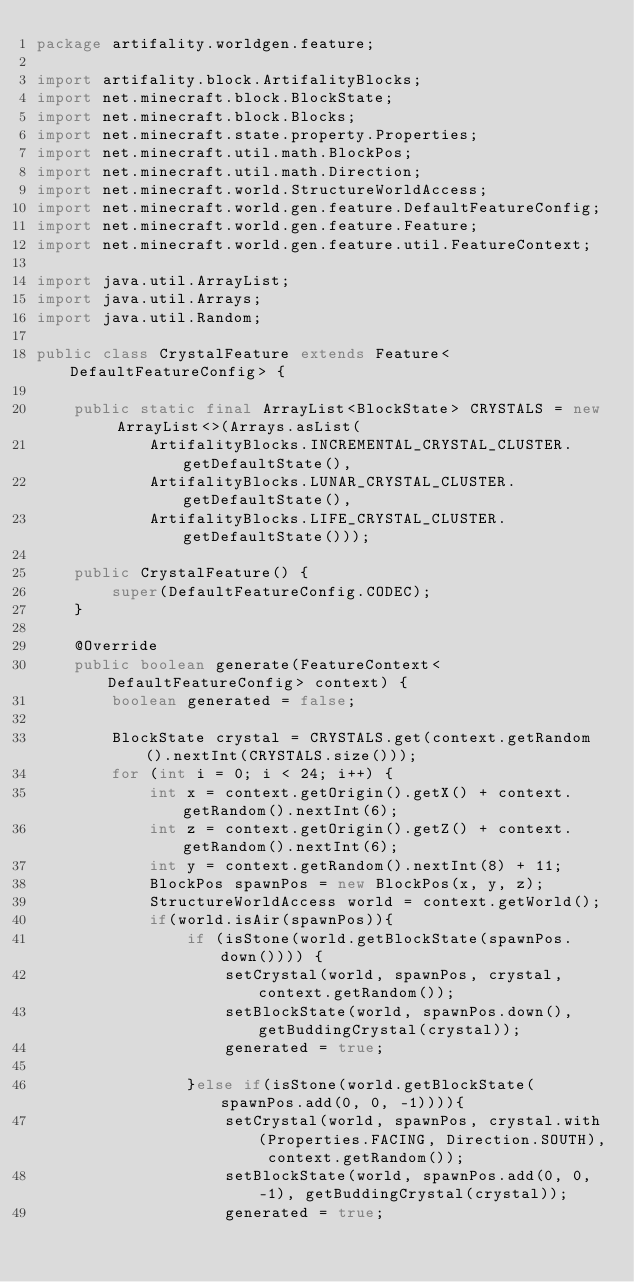Convert code to text. <code><loc_0><loc_0><loc_500><loc_500><_Java_>package artifality.worldgen.feature;

import artifality.block.ArtifalityBlocks;
import net.minecraft.block.BlockState;
import net.minecraft.block.Blocks;
import net.minecraft.state.property.Properties;
import net.minecraft.util.math.BlockPos;
import net.minecraft.util.math.Direction;
import net.minecraft.world.StructureWorldAccess;
import net.minecraft.world.gen.feature.DefaultFeatureConfig;
import net.minecraft.world.gen.feature.Feature;
import net.minecraft.world.gen.feature.util.FeatureContext;

import java.util.ArrayList;
import java.util.Arrays;
import java.util.Random;

public class CrystalFeature extends Feature<DefaultFeatureConfig> {

    public static final ArrayList<BlockState> CRYSTALS = new ArrayList<>(Arrays.asList(
            ArtifalityBlocks.INCREMENTAL_CRYSTAL_CLUSTER.getDefaultState(),
            ArtifalityBlocks.LUNAR_CRYSTAL_CLUSTER.getDefaultState(),
            ArtifalityBlocks.LIFE_CRYSTAL_CLUSTER.getDefaultState()));

    public CrystalFeature() {
        super(DefaultFeatureConfig.CODEC);
    }

    @Override
    public boolean generate(FeatureContext<DefaultFeatureConfig> context) {
        boolean generated = false;

        BlockState crystal = CRYSTALS.get(context.getRandom().nextInt(CRYSTALS.size()));
        for (int i = 0; i < 24; i++) {
            int x = context.getOrigin().getX() + context.getRandom().nextInt(6);
            int z = context.getOrigin().getZ() + context.getRandom().nextInt(6);
            int y = context.getRandom().nextInt(8) + 11;
            BlockPos spawnPos = new BlockPos(x, y, z);
            StructureWorldAccess world = context.getWorld();
            if(world.isAir(spawnPos)){
                if (isStone(world.getBlockState(spawnPos.down()))) {
                    setCrystal(world, spawnPos, crystal, context.getRandom());
                    setBlockState(world, spawnPos.down(), getBuddingCrystal(crystal));
                    generated = true;

                }else if(isStone(world.getBlockState(spawnPos.add(0, 0, -1)))){
                    setCrystal(world, spawnPos, crystal.with(Properties.FACING, Direction.SOUTH), context.getRandom());
                    setBlockState(world, spawnPos.add(0, 0, -1), getBuddingCrystal(crystal));
                    generated = true;
</code> 